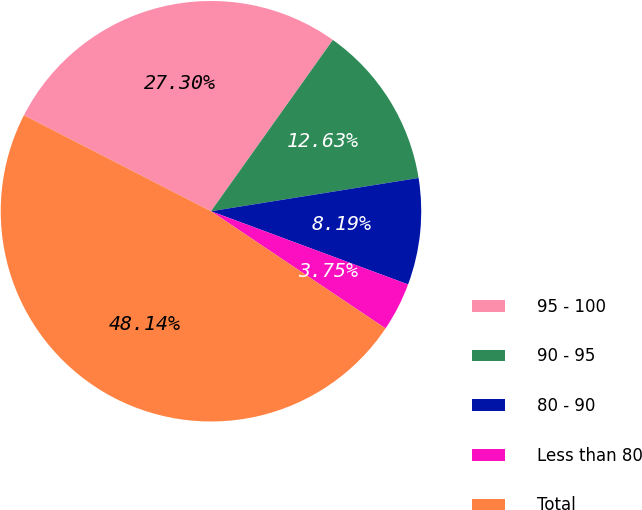Convert chart to OTSL. <chart><loc_0><loc_0><loc_500><loc_500><pie_chart><fcel>95 - 100<fcel>90 - 95<fcel>80 - 90<fcel>Less than 80<fcel>Total<nl><fcel>27.3%<fcel>12.63%<fcel>8.19%<fcel>3.75%<fcel>48.14%<nl></chart> 